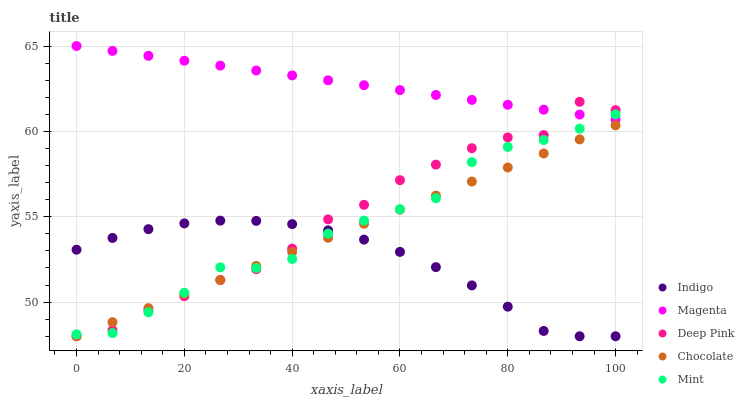Does Indigo have the minimum area under the curve?
Answer yes or no. Yes. Does Magenta have the maximum area under the curve?
Answer yes or no. Yes. Does Deep Pink have the minimum area under the curve?
Answer yes or no. No. Does Deep Pink have the maximum area under the curve?
Answer yes or no. No. Is Magenta the smoothest?
Answer yes or no. Yes. Is Deep Pink the roughest?
Answer yes or no. Yes. Is Deep Pink the smoothest?
Answer yes or no. No. Is Magenta the roughest?
Answer yes or no. No. Does Deep Pink have the lowest value?
Answer yes or no. Yes. Does Magenta have the lowest value?
Answer yes or no. No. Does Magenta have the highest value?
Answer yes or no. Yes. Does Deep Pink have the highest value?
Answer yes or no. No. Is Indigo less than Magenta?
Answer yes or no. Yes. Is Magenta greater than Indigo?
Answer yes or no. Yes. Does Deep Pink intersect Mint?
Answer yes or no. Yes. Is Deep Pink less than Mint?
Answer yes or no. No. Is Deep Pink greater than Mint?
Answer yes or no. No. Does Indigo intersect Magenta?
Answer yes or no. No. 